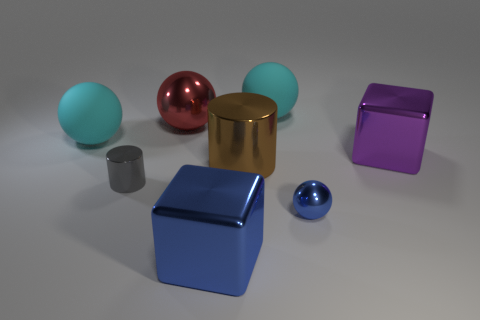Are the objects arranged in any particular pattern? The objects seem to be arranged randomly on a flat surface. There is a balance of shapes and colors, but there doesn't appear to be a deliberate pattern to their placement, aside from spacing that avoids any overlap in the visible perspective. 